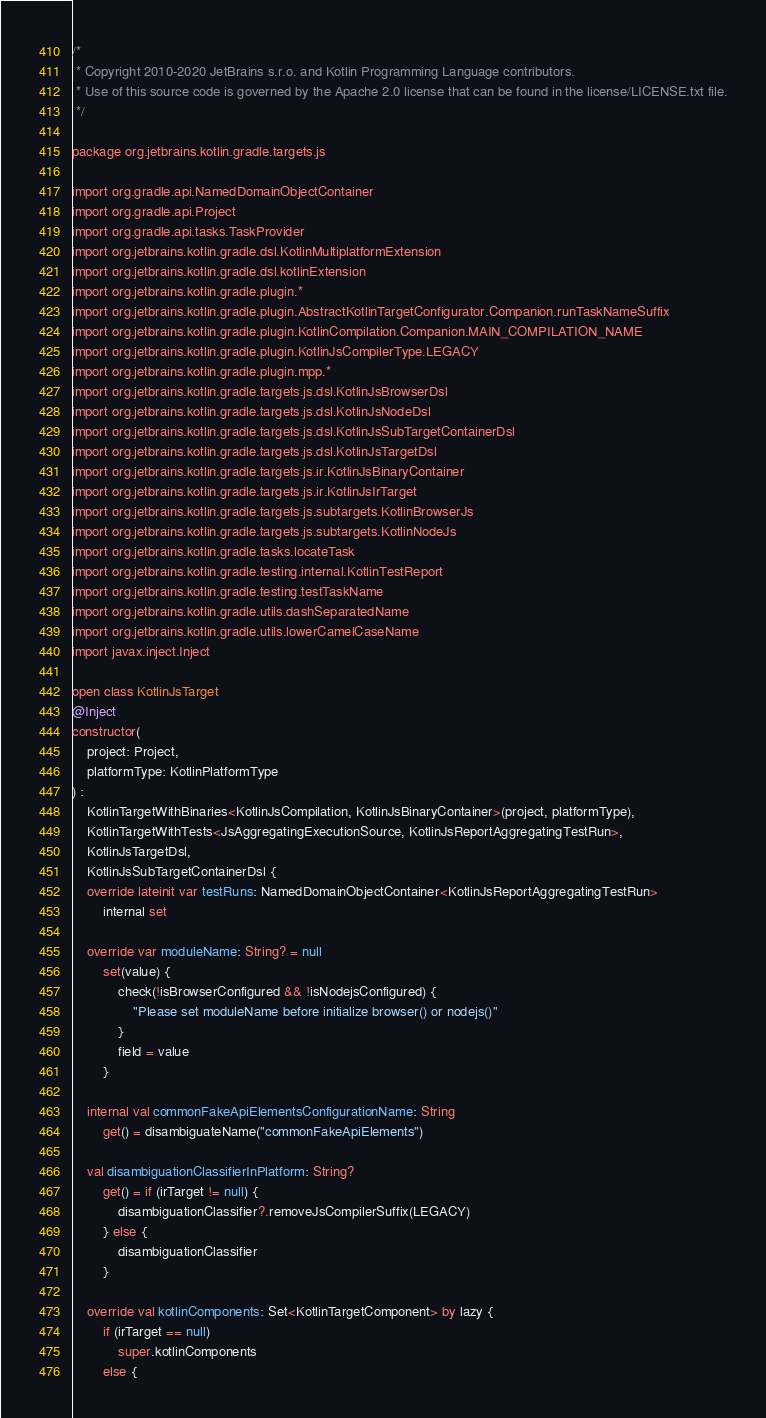<code> <loc_0><loc_0><loc_500><loc_500><_Kotlin_>/*
 * Copyright 2010-2020 JetBrains s.r.o. and Kotlin Programming Language contributors.
 * Use of this source code is governed by the Apache 2.0 license that can be found in the license/LICENSE.txt file.
 */

package org.jetbrains.kotlin.gradle.targets.js

import org.gradle.api.NamedDomainObjectContainer
import org.gradle.api.Project
import org.gradle.api.tasks.TaskProvider
import org.jetbrains.kotlin.gradle.dsl.KotlinMultiplatformExtension
import org.jetbrains.kotlin.gradle.dsl.kotlinExtension
import org.jetbrains.kotlin.gradle.plugin.*
import org.jetbrains.kotlin.gradle.plugin.AbstractKotlinTargetConfigurator.Companion.runTaskNameSuffix
import org.jetbrains.kotlin.gradle.plugin.KotlinCompilation.Companion.MAIN_COMPILATION_NAME
import org.jetbrains.kotlin.gradle.plugin.KotlinJsCompilerType.LEGACY
import org.jetbrains.kotlin.gradle.plugin.mpp.*
import org.jetbrains.kotlin.gradle.targets.js.dsl.KotlinJsBrowserDsl
import org.jetbrains.kotlin.gradle.targets.js.dsl.KotlinJsNodeDsl
import org.jetbrains.kotlin.gradle.targets.js.dsl.KotlinJsSubTargetContainerDsl
import org.jetbrains.kotlin.gradle.targets.js.dsl.KotlinJsTargetDsl
import org.jetbrains.kotlin.gradle.targets.js.ir.KotlinJsBinaryContainer
import org.jetbrains.kotlin.gradle.targets.js.ir.KotlinJsIrTarget
import org.jetbrains.kotlin.gradle.targets.js.subtargets.KotlinBrowserJs
import org.jetbrains.kotlin.gradle.targets.js.subtargets.KotlinNodeJs
import org.jetbrains.kotlin.gradle.tasks.locateTask
import org.jetbrains.kotlin.gradle.testing.internal.KotlinTestReport
import org.jetbrains.kotlin.gradle.testing.testTaskName
import org.jetbrains.kotlin.gradle.utils.dashSeparatedName
import org.jetbrains.kotlin.gradle.utils.lowerCamelCaseName
import javax.inject.Inject

open class KotlinJsTarget
@Inject
constructor(
    project: Project,
    platformType: KotlinPlatformType
) :
    KotlinTargetWithBinaries<KotlinJsCompilation, KotlinJsBinaryContainer>(project, platformType),
    KotlinTargetWithTests<JsAggregatingExecutionSource, KotlinJsReportAggregatingTestRun>,
    KotlinJsTargetDsl,
    KotlinJsSubTargetContainerDsl {
    override lateinit var testRuns: NamedDomainObjectContainer<KotlinJsReportAggregatingTestRun>
        internal set

    override var moduleName: String? = null
        set(value) {
            check(!isBrowserConfigured && !isNodejsConfigured) {
                "Please set moduleName before initialize browser() or nodejs()"
            }
            field = value
        }

    internal val commonFakeApiElementsConfigurationName: String
        get() = disambiguateName("commonFakeApiElements")

    val disambiguationClassifierInPlatform: String?
        get() = if (irTarget != null) {
            disambiguationClassifier?.removeJsCompilerSuffix(LEGACY)
        } else {
            disambiguationClassifier
        }

    override val kotlinComponents: Set<KotlinTargetComponent> by lazy {
        if (irTarget == null)
            super.kotlinComponents
        else {</code> 